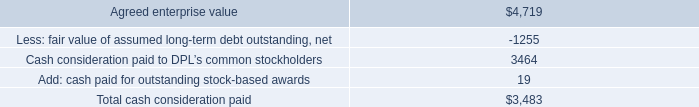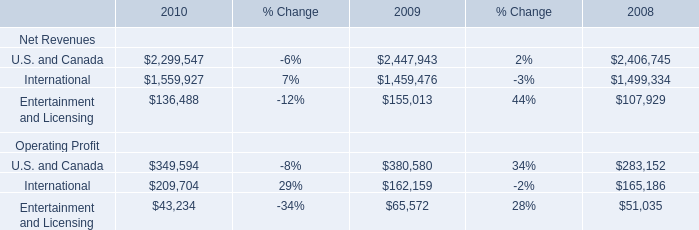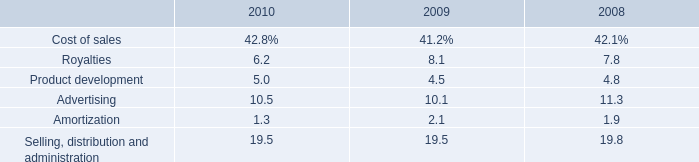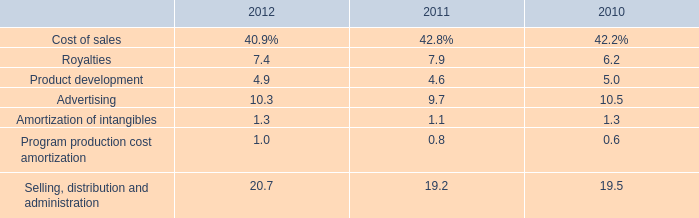Which year is Net Revenues for Entertainment and Licensing greater than 150000 ? 
Answer: 2009. 